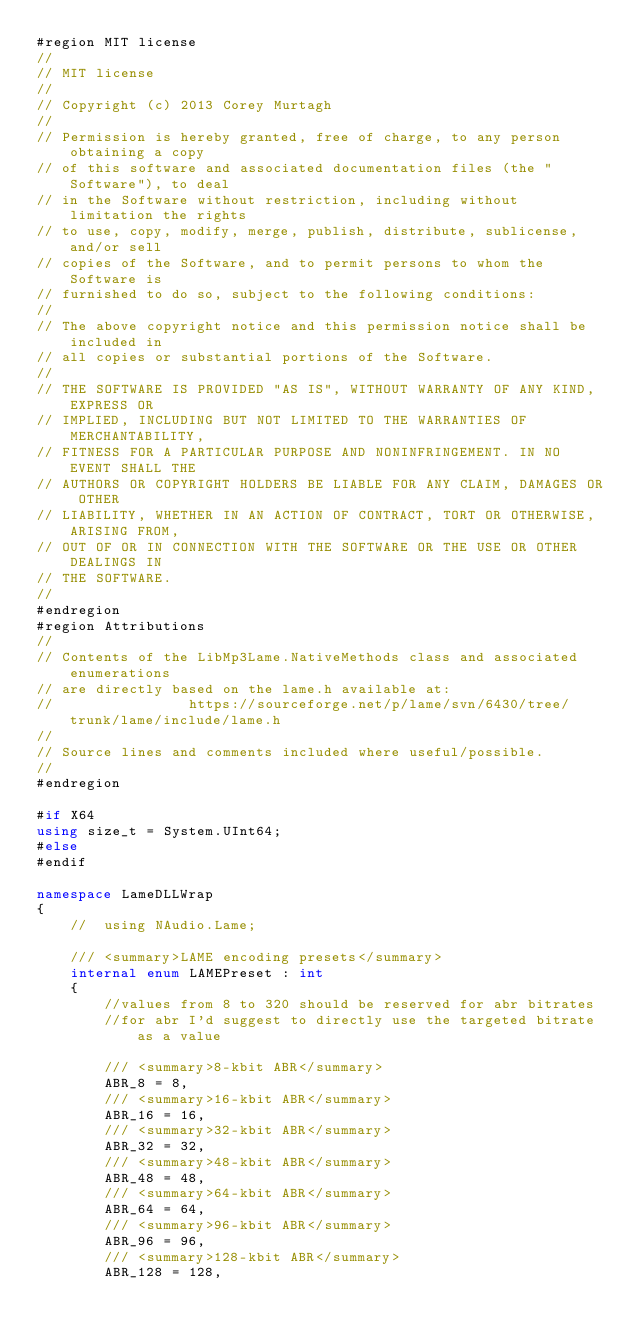Convert code to text. <code><loc_0><loc_0><loc_500><loc_500><_C#_>#region MIT license
// 
// MIT license
//
// Copyright (c) 2013 Corey Murtagh
// 
// Permission is hereby granted, free of charge, to any person obtaining a copy
// of this software and associated documentation files (the "Software"), to deal
// in the Software without restriction, including without limitation the rights
// to use, copy, modify, merge, publish, distribute, sublicense, and/or sell
// copies of the Software, and to permit persons to whom the Software is
// furnished to do so, subject to the following conditions:
// 
// The above copyright notice and this permission notice shall be included in
// all copies or substantial portions of the Software.
// 
// THE SOFTWARE IS PROVIDED "AS IS", WITHOUT WARRANTY OF ANY KIND, EXPRESS OR
// IMPLIED, INCLUDING BUT NOT LIMITED TO THE WARRANTIES OF MERCHANTABILITY,
// FITNESS FOR A PARTICULAR PURPOSE AND NONINFRINGEMENT. IN NO EVENT SHALL THE
// AUTHORS OR COPYRIGHT HOLDERS BE LIABLE FOR ANY CLAIM, DAMAGES OR OTHER
// LIABILITY, WHETHER IN AN ACTION OF CONTRACT, TORT OR OTHERWISE, ARISING FROM,
// OUT OF OR IN CONNECTION WITH THE SOFTWARE OR THE USE OR OTHER DEALINGS IN
// THE SOFTWARE.
// 
#endregion
#region Attributions
//
// Contents of the LibMp3Lame.NativeMethods class and associated enumerations 
// are directly based on the lame.h available at:
//                https://sourceforge.net/p/lame/svn/6430/tree/trunk/lame/include/lame.h
//
// Source lines and comments included where useful/possible.
//
#endregion

#if X64
using size_t = System.UInt64;
#else
#endif

namespace LameDLLWrap
{
    //	using NAudio.Lame;

    /// <summary>LAME encoding presets</summary>
    internal enum LAMEPreset : int
    {
        //values from 8 to 320 should be reserved for abr bitrates
        //for abr I'd suggest to directly use the targeted bitrate as a value

        /// <summary>8-kbit ABR</summary>
        ABR_8 = 8,
        /// <summary>16-kbit ABR</summary>
        ABR_16 = 16,
        /// <summary>32-kbit ABR</summary>
        ABR_32 = 32,
        /// <summary>48-kbit ABR</summary>
        ABR_48 = 48,
        /// <summary>64-kbit ABR</summary>
        ABR_64 = 64,
        /// <summary>96-kbit ABR</summary>
        ABR_96 = 96,
        /// <summary>128-kbit ABR</summary>
        ABR_128 = 128,</code> 